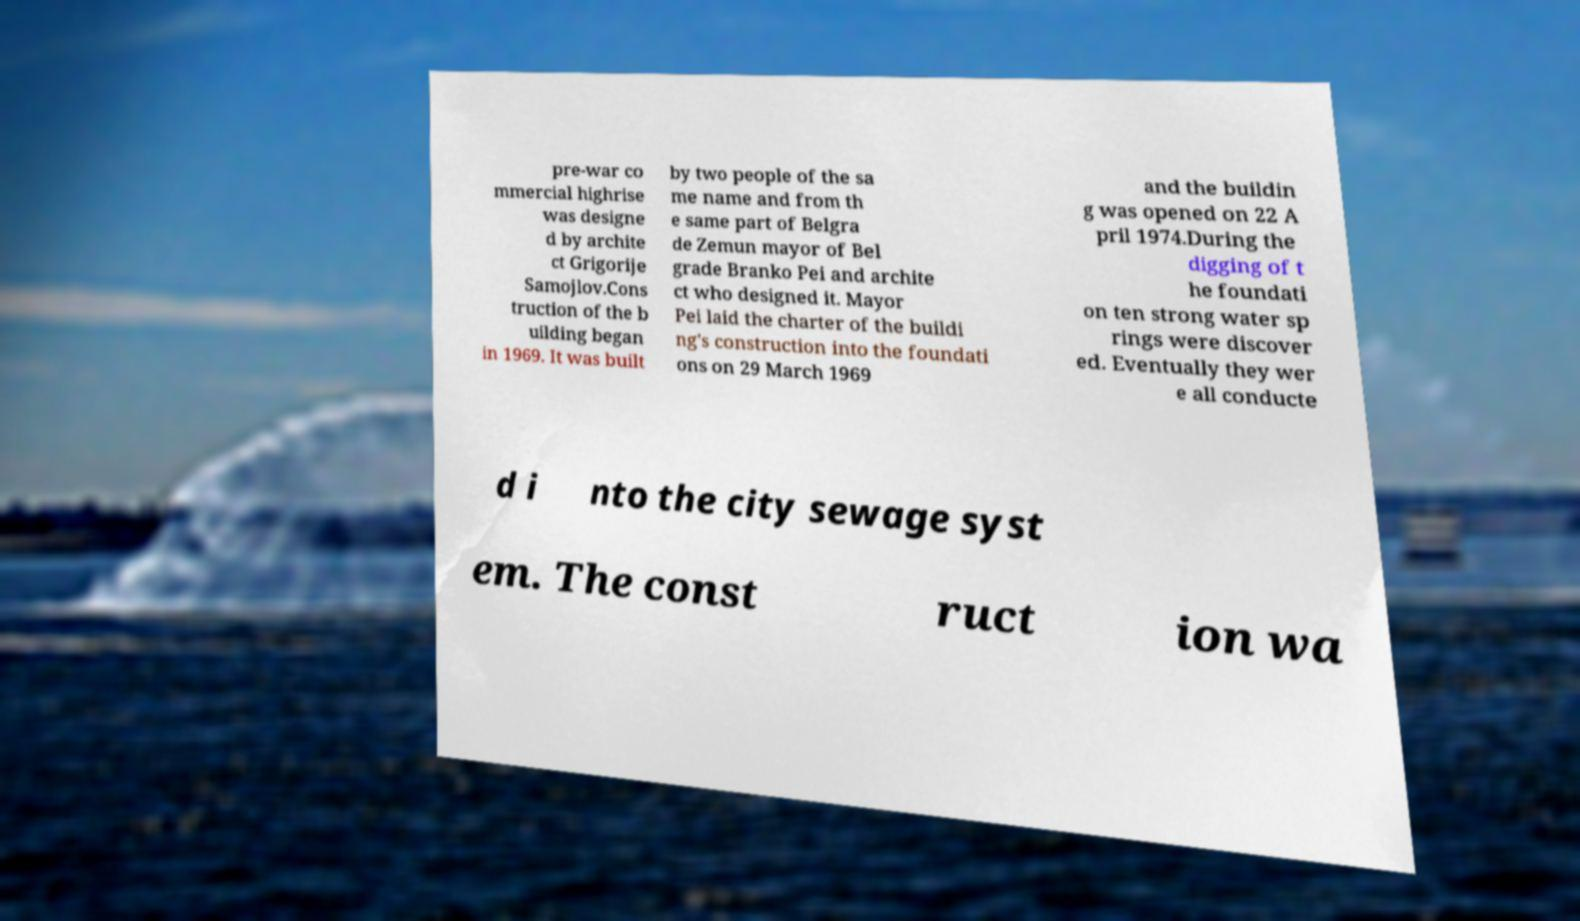There's text embedded in this image that I need extracted. Can you transcribe it verbatim? pre-war co mmercial highrise was designe d by archite ct Grigorije Samojlov.Cons truction of the b uilding began in 1969. It was built by two people of the sa me name and from th e same part of Belgra de Zemun mayor of Bel grade Branko Pei and archite ct who designed it. Mayor Pei laid the charter of the buildi ng's construction into the foundati ons on 29 March 1969 and the buildin g was opened on 22 A pril 1974.During the digging of t he foundati on ten strong water sp rings were discover ed. Eventually they wer e all conducte d i nto the city sewage syst em. The const ruct ion wa 